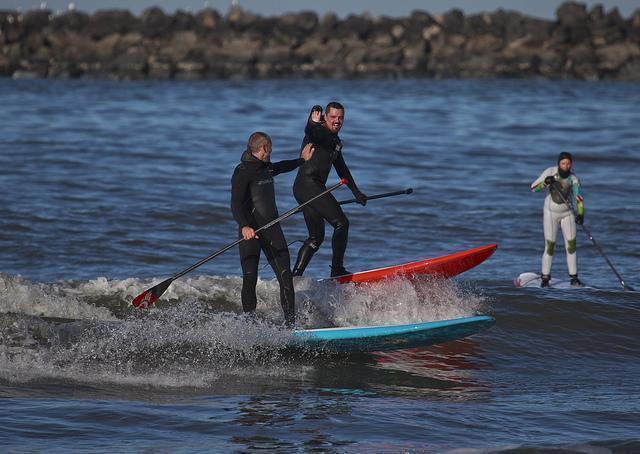Which artist depicted Polynesians practicing this sport on the Sandwich Islands?
Select the accurate answer and provide justification: `Answer: choice
Rationale: srationale.`
Options: Paul gauguin, georges seurat, michael donahue, john webber. Answer: john webber.
Rationale: The artist was webber. 